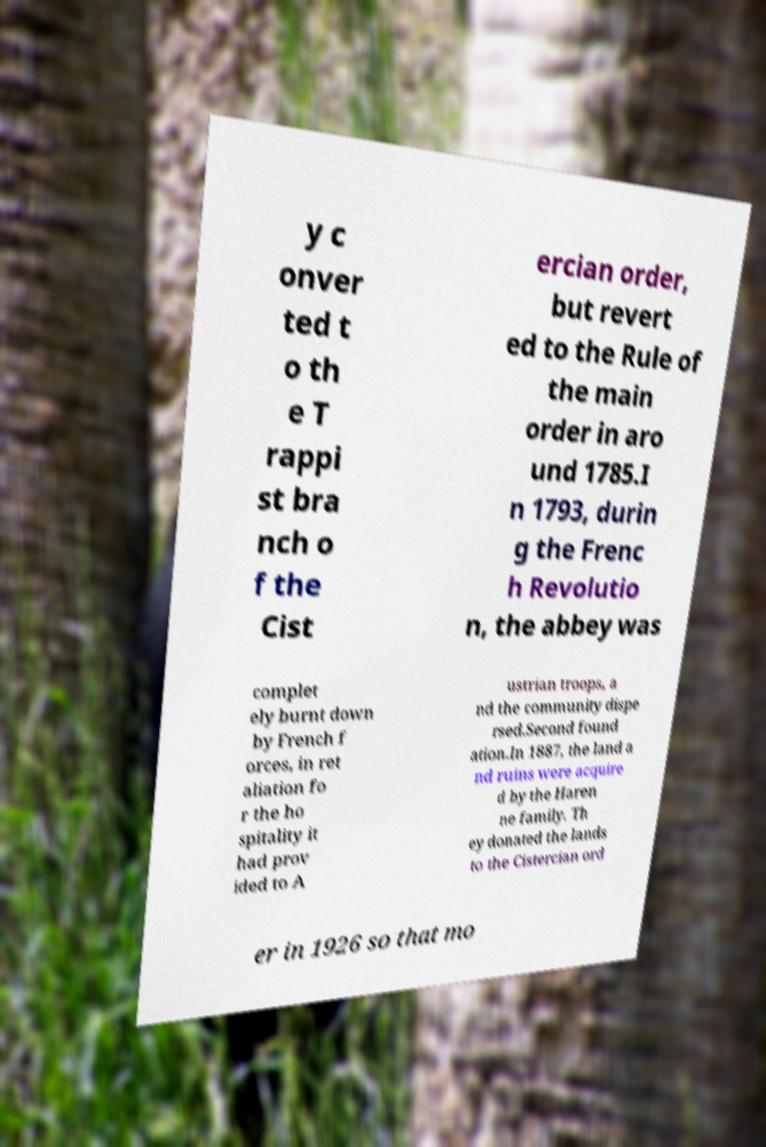Can you accurately transcribe the text from the provided image for me? y c onver ted t o th e T rappi st bra nch o f the Cist ercian order, but revert ed to the Rule of the main order in aro und 1785.I n 1793, durin g the Frenc h Revolutio n, the abbey was complet ely burnt down by French f orces, in ret aliation fo r the ho spitality it had prov ided to A ustrian troops, a nd the community dispe rsed.Second found ation.In 1887, the land a nd ruins were acquire d by the Haren ne family. Th ey donated the lands to the Cistercian ord er in 1926 so that mo 